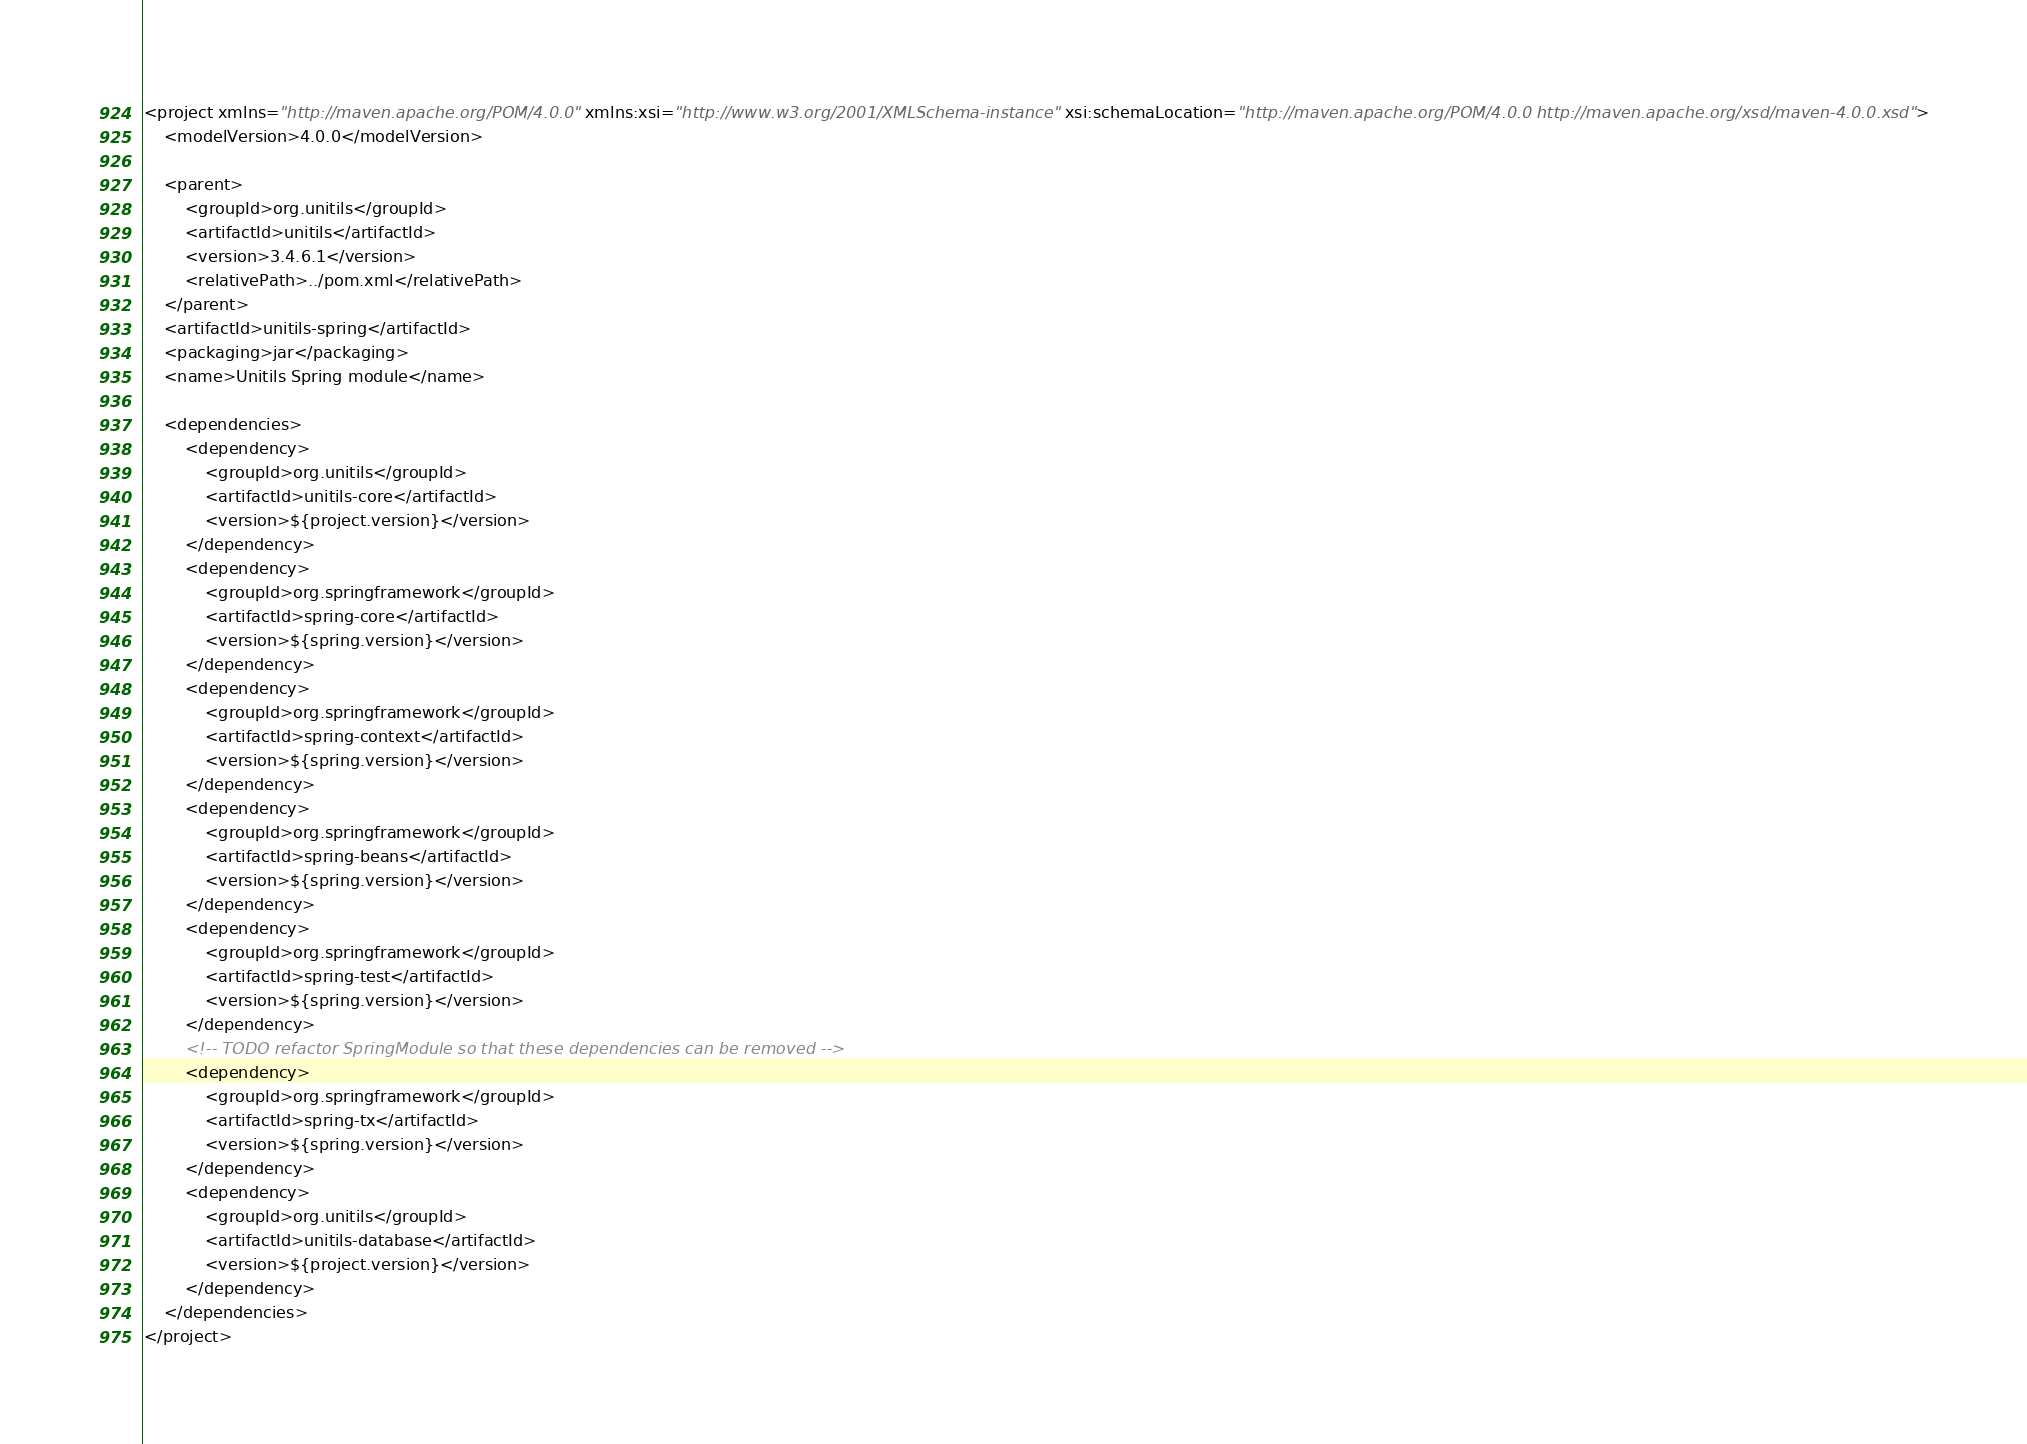<code> <loc_0><loc_0><loc_500><loc_500><_XML_><project xmlns="http://maven.apache.org/POM/4.0.0" xmlns:xsi="http://www.w3.org/2001/XMLSchema-instance" xsi:schemaLocation="http://maven.apache.org/POM/4.0.0 http://maven.apache.org/xsd/maven-4.0.0.xsd">
    <modelVersion>4.0.0</modelVersion>

    <parent>
        <groupId>org.unitils</groupId>
        <artifactId>unitils</artifactId>
        <version>3.4.6.1</version>
        <relativePath>../pom.xml</relativePath>
    </parent>
    <artifactId>unitils-spring</artifactId>
    <packaging>jar</packaging>
    <name>Unitils Spring module</name>

    <dependencies>
        <dependency>
            <groupId>org.unitils</groupId>
            <artifactId>unitils-core</artifactId>
            <version>${project.version}</version>
        </dependency>
        <dependency>
            <groupId>org.springframework</groupId>
            <artifactId>spring-core</artifactId>
            <version>${spring.version}</version>
        </dependency>
        <dependency>
            <groupId>org.springframework</groupId>
            <artifactId>spring-context</artifactId>
            <version>${spring.version}</version>
        </dependency>
        <dependency>
            <groupId>org.springframework</groupId>
            <artifactId>spring-beans</artifactId>
            <version>${spring.version}</version>
        </dependency>
        <dependency>
            <groupId>org.springframework</groupId>
            <artifactId>spring-test</artifactId>
            <version>${spring.version}</version>
        </dependency>
        <!-- TODO refactor SpringModule so that these dependencies can be removed -->
        <dependency>
            <groupId>org.springframework</groupId>
            <artifactId>spring-tx</artifactId>
            <version>${spring.version}</version>
        </dependency>
        <dependency>
            <groupId>org.unitils</groupId>
            <artifactId>unitils-database</artifactId>
            <version>${project.version}</version>
        </dependency>
    </dependencies>
</project></code> 